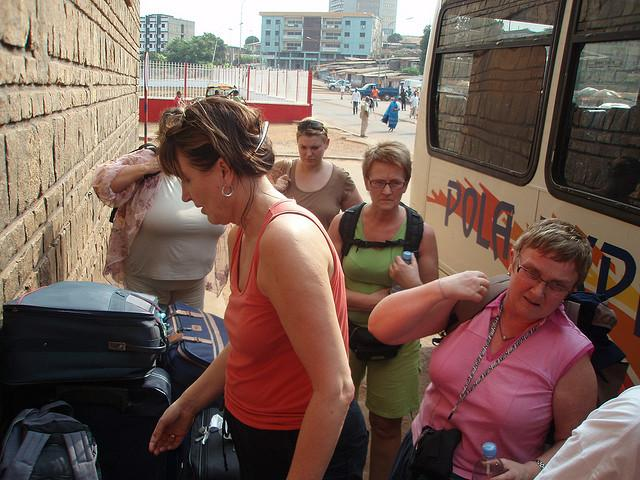What are the buildings in the background likely used for? housing 